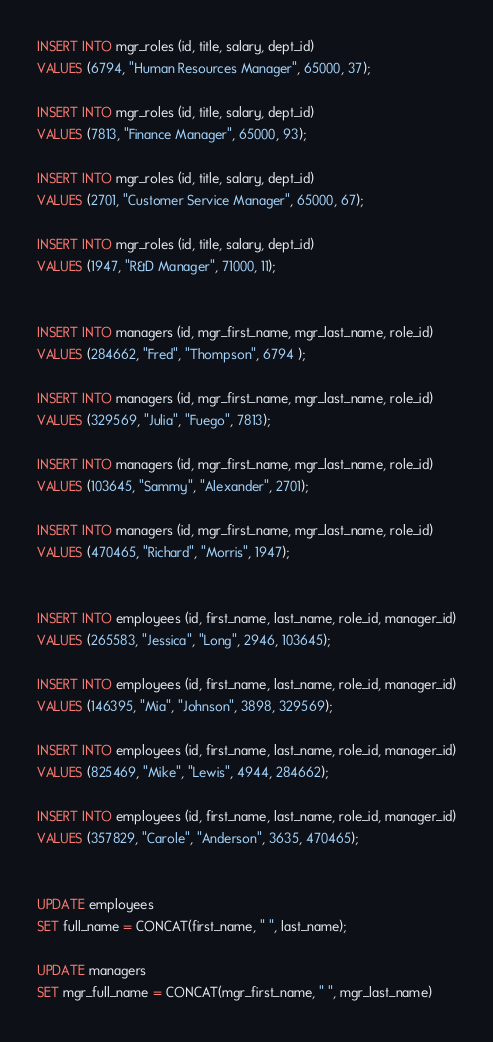<code> <loc_0><loc_0><loc_500><loc_500><_SQL_>

INSERT INTO mgr_roles (id, title, salary, dept_id)
VALUES (6794, "Human Resources Manager", 65000, 37);

INSERT INTO mgr_roles (id, title, salary, dept_id)
VALUES (7813, "Finance Manager", 65000, 93);

INSERT INTO mgr_roles (id, title, salary, dept_id)
VALUES (2701, "Customer Service Manager", 65000, 67);

INSERT INTO mgr_roles (id, title, salary, dept_id)
VALUES (1947, "R&D Manager", 71000, 11);


INSERT INTO managers (id, mgr_first_name, mgr_last_name, role_id)
VALUES (284662, "Fred", "Thompson", 6794 );

INSERT INTO managers (id, mgr_first_name, mgr_last_name, role_id)
VALUES (329569, "Julia", "Fuego", 7813);

INSERT INTO managers (id, mgr_first_name, mgr_last_name, role_id)
VALUES (103645, "Sammy", "Alexander", 2701);

INSERT INTO managers (id, mgr_first_name, mgr_last_name, role_id)
VALUES (470465, "Richard", "Morris", 1947);


INSERT INTO employees (id, first_name, last_name, role_id, manager_id)
VALUES (265583, "Jessica", "Long", 2946, 103645);

INSERT INTO employees (id, first_name, last_name, role_id, manager_id)
VALUES (146395, "Mia", "Johnson", 3898, 329569);

INSERT INTO employees (id, first_name, last_name, role_id, manager_id)
VALUES (825469, "Mike", "Lewis", 4944, 284662);

INSERT INTO employees (id, first_name, last_name, role_id, manager_id)
VALUES (357829, "Carole", "Anderson", 3635, 470465);


UPDATE employees
SET full_name = CONCAT(first_name, " ", last_name);

UPDATE managers
SET mgr_full_name = CONCAT(mgr_first_name, " ", mgr_last_name)
</code> 